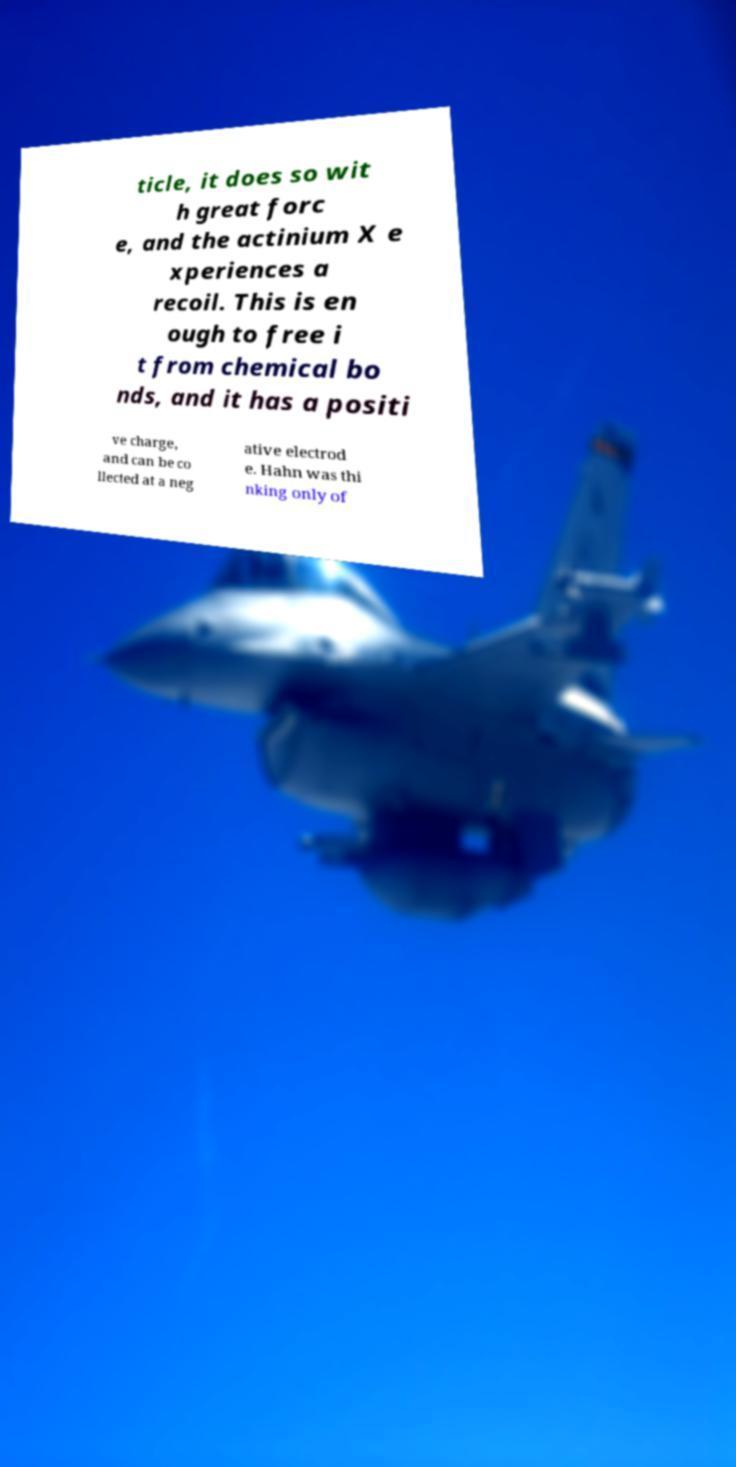Could you extract and type out the text from this image? ticle, it does so wit h great forc e, and the actinium X e xperiences a recoil. This is en ough to free i t from chemical bo nds, and it has a positi ve charge, and can be co llected at a neg ative electrod e. Hahn was thi nking only of 